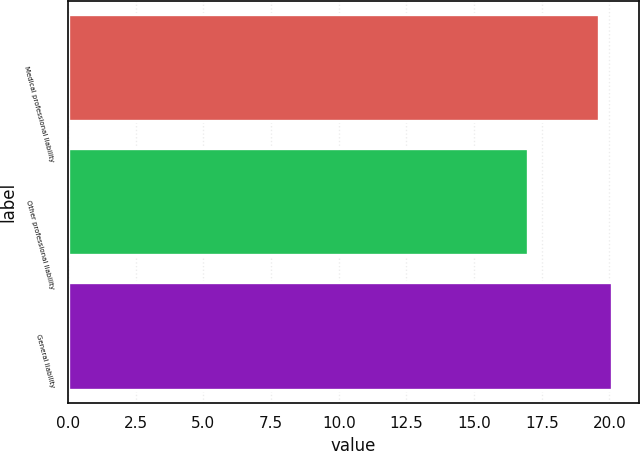Convert chart. <chart><loc_0><loc_0><loc_500><loc_500><bar_chart><fcel>Medical professional liability<fcel>Other professional liability<fcel>General liability<nl><fcel>19.6<fcel>17<fcel>20.1<nl></chart> 